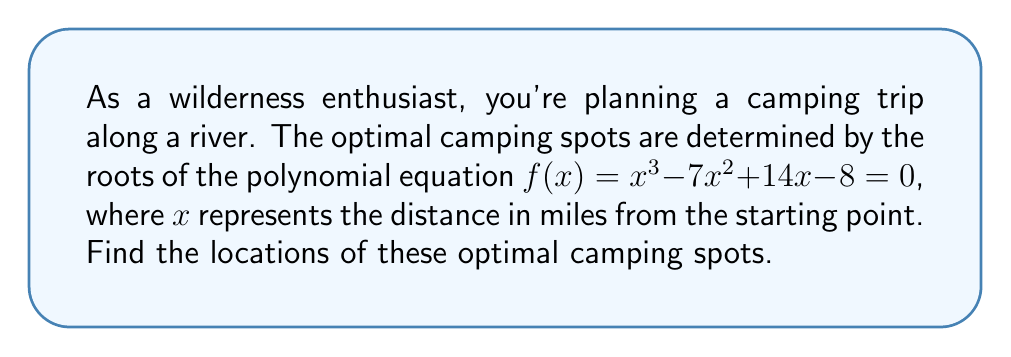Help me with this question. To find the optimal camping locations, we need to determine the roots of the given polynomial equation. Let's solve this step-by-step:

1) First, let's try to factor out any common factors:
   $f(x) = x^3 - 7x^2 + 14x - 8$
   There are no common factors, so we move to the next step.

2) We can use the rational root theorem to find potential rational roots. The possible rational roots are the factors of the constant term (8): ±1, ±2, ±4, ±8.

3) Let's test these values:
   $f(1) = 1 - 7 + 14 - 8 = 0$
   We found our first root: $x = 1$

4) Now we can factor out $(x-1)$:
   $f(x) = (x-1)(x^2 - 6x + 8)$

5) We can solve the quadratic equation $x^2 - 6x + 8 = 0$ using the quadratic formula:
   $x = \frac{-b \pm \sqrt{b^2 - 4ac}}{2a}$

   $x = \frac{6 \pm \sqrt{36 - 32}}{2} = \frac{6 \pm \sqrt{4}}{2} = \frac{6 \pm 2}{2}$

6) This gives us two more roots:
   $x = \frac{6 + 2}{2} = 4$ and $x = \frac{6 - 2}{2} = 2$

Therefore, the optimal camping spots are located at 1 mile, 2 miles, and 4 miles from the starting point along the river.
Answer: 1, 2, and 4 miles from the starting point 